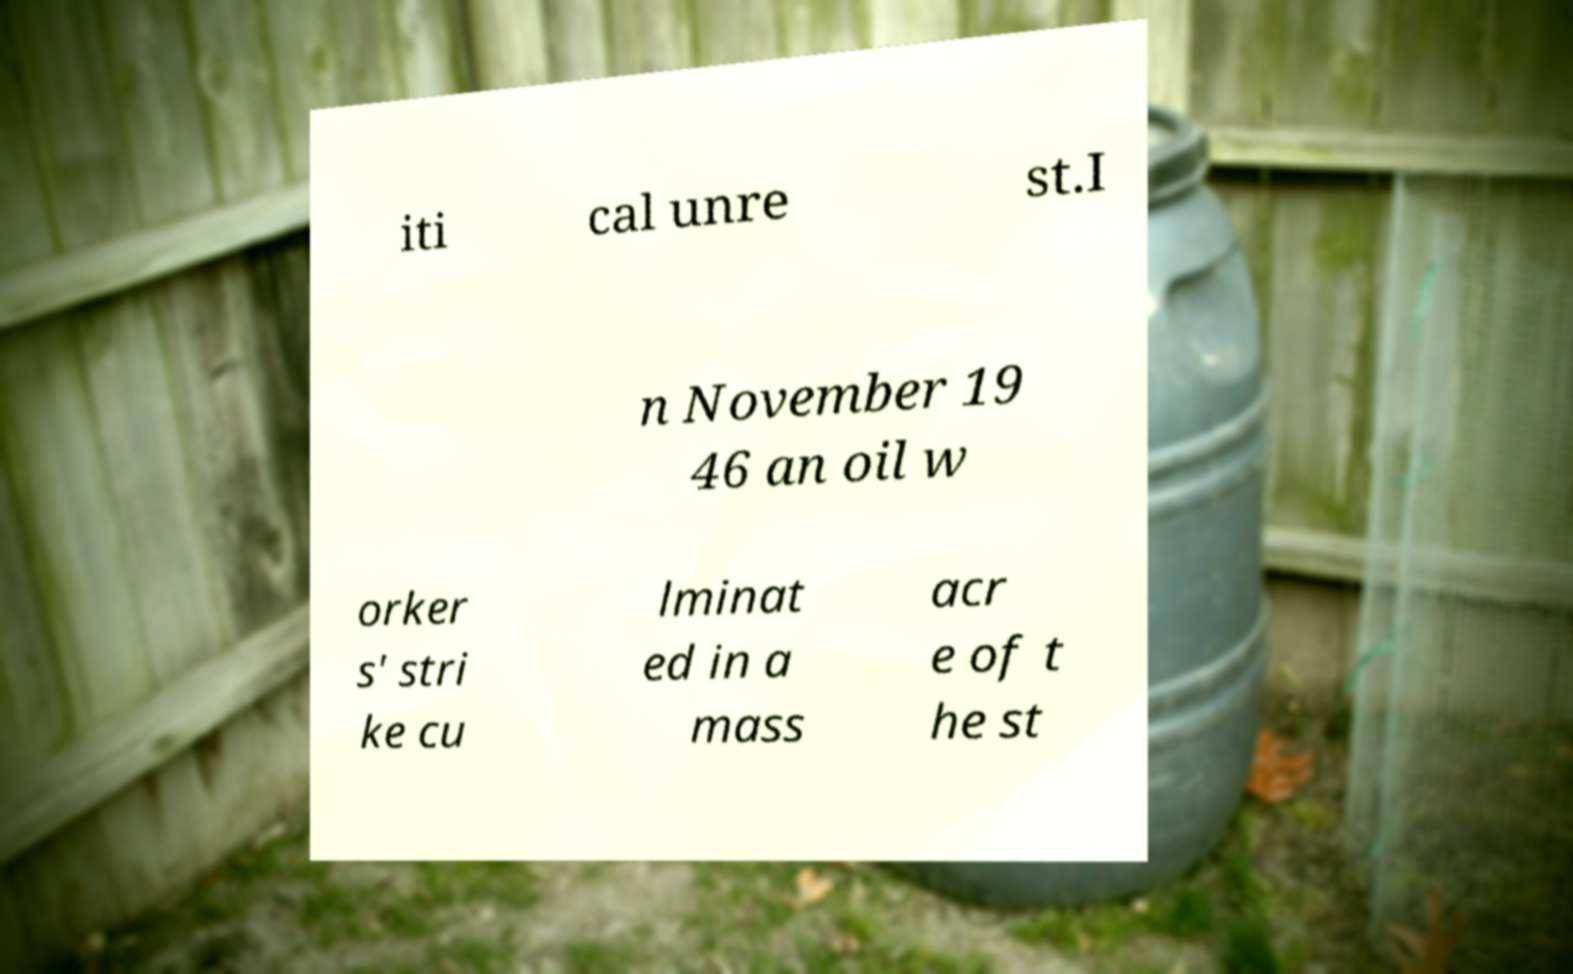Please read and relay the text visible in this image. What does it say? iti cal unre st.I n November 19 46 an oil w orker s' stri ke cu lminat ed in a mass acr e of t he st 